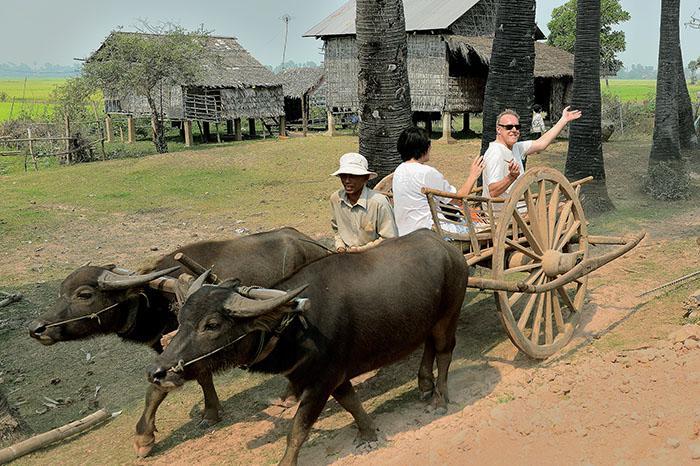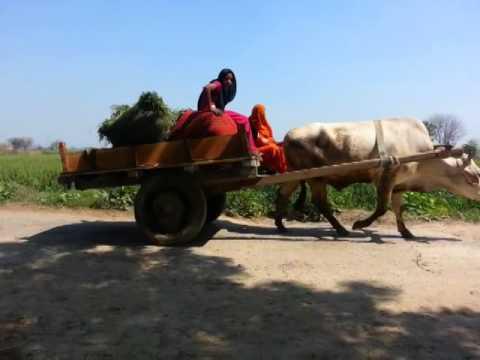The first image is the image on the left, the second image is the image on the right. Given the left and right images, does the statement "Four oxen are pulling carts with at least one person riding in them." hold true? Answer yes or no. No. The first image is the image on the left, the second image is the image on the right. For the images shown, is this caption "The oxen in the image on the right are wearing decorative headgear." true? Answer yes or no. No. 